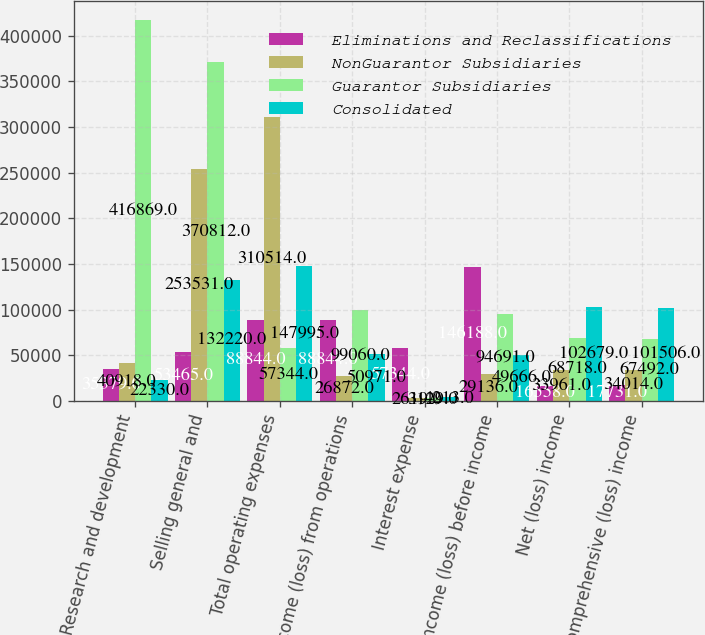Convert chart to OTSL. <chart><loc_0><loc_0><loc_500><loc_500><stacked_bar_chart><ecel><fcel>Research and development<fcel>Selling general and<fcel>Total operating expenses<fcel>Income (loss) from operations<fcel>Interest expense<fcel>Income (loss) before income<fcel>Net (loss) income<fcel>Comprehensive (loss) income<nl><fcel>Eliminations and Reclassifications<fcel>35379<fcel>53465<fcel>88844<fcel>88844<fcel>57344<fcel>146188<fcel>16558<fcel>17731<nl><fcel>NonGuarantor Subsidiaries<fcel>40918<fcel>253531<fcel>310514<fcel>26872<fcel>2619<fcel>29136<fcel>33961<fcel>34014<nl><fcel>Guarantor Subsidiaries<fcel>416869<fcel>370812<fcel>57344<fcel>99060<fcel>3129<fcel>94691<fcel>68718<fcel>67492<nl><fcel>Consolidated<fcel>22330<fcel>132220<fcel>147995<fcel>50971<fcel>4213<fcel>49666<fcel>102679<fcel>101506<nl></chart> 